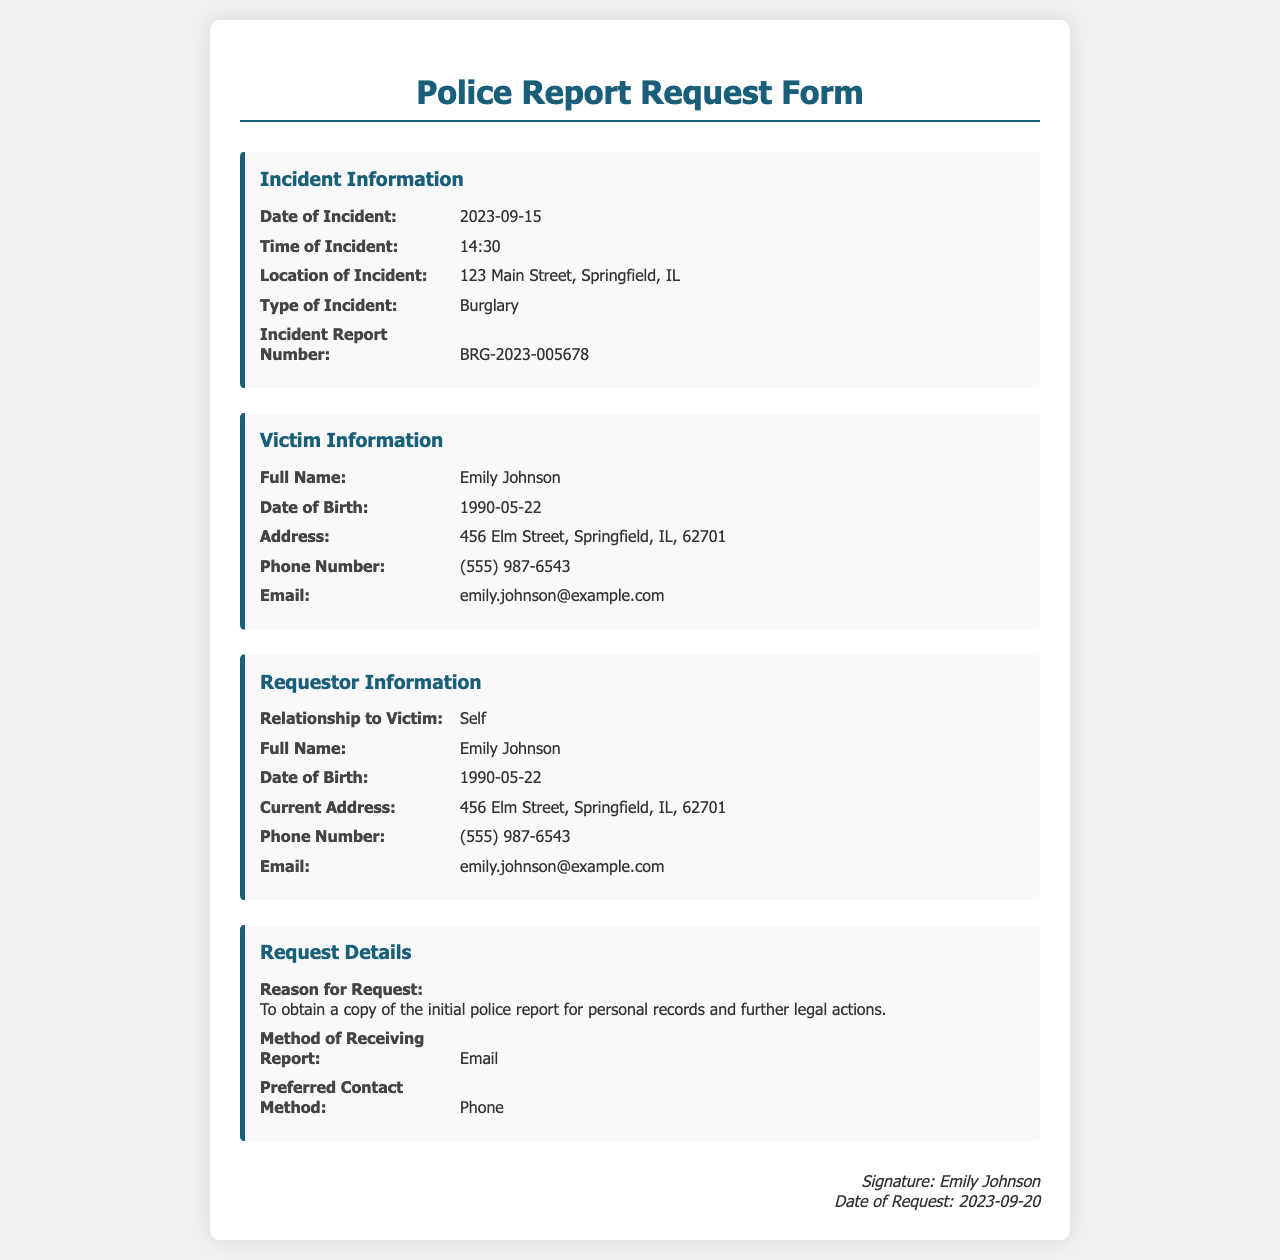what is the date of the incident? The date of the incident is provided in the form under the Incident Information section.
Answer: 2023-09-15 what is the type of incident? The type of incident is specified in the form in the Incident Information section.
Answer: Burglary who is the victim of the incident? The victim's full name is stated in the Victim Information section.
Answer: Emily Johnson what is the Incident Report Number? The Incident Report Number is listed in the Incident Information section of the form.
Answer: BRG-2023-005678 how will the police report be received? The method of receiving the report is indicated in the Request Details section of the form.
Answer: Email what is the victim's phone number? The victim's phone number is provided in the Victim Information section of the form.
Answer: (555) 987-6543 what is the reason for the request? The reason for the request is specified in the Request Details section of the document.
Answer: To obtain a copy of the initial police report for personal records and further legal actions who is making the request? The individual making the request is identified in the Requestor Information section.
Answer: Emily Johnson 